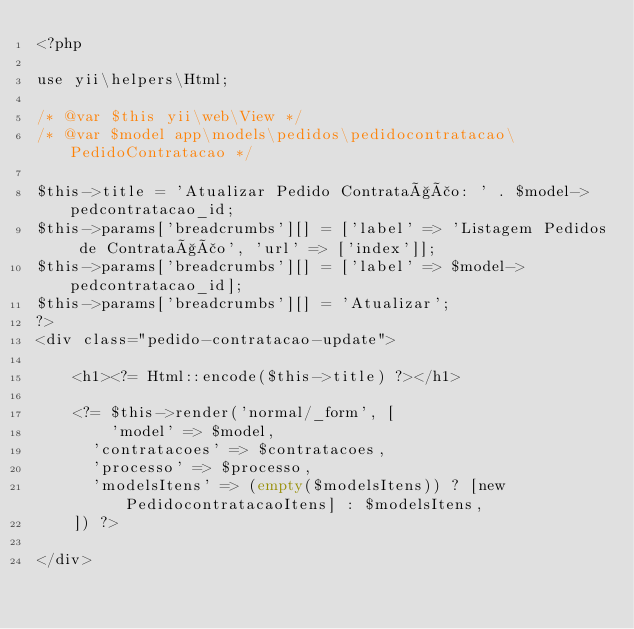<code> <loc_0><loc_0><loc_500><loc_500><_PHP_><?php

use yii\helpers\Html;

/* @var $this yii\web\View */
/* @var $model app\models\pedidos\pedidocontratacao\PedidoContratacao */

$this->title = 'Atualizar Pedido Contratação: ' . $model->pedcontratacao_id;
$this->params['breadcrumbs'][] = ['label' => 'Listagem Pedidos de Contratação', 'url' => ['index']];
$this->params['breadcrumbs'][] = ['label' => $model->pedcontratacao_id];
$this->params['breadcrumbs'][] = 'Atualizar';
?>
<div class="pedido-contratacao-update">

    <h1><?= Html::encode($this->title) ?></h1>

    <?= $this->render('normal/_form', [
        'model' => $model,
    	'contratacoes' => $contratacoes,
    	'processo' => $processo,
    	'modelsItens' => (empty($modelsItens)) ? [new PedidocontratacaoItens] : $modelsItens,
    ]) ?>

</div>
</code> 